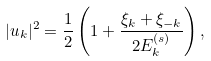<formula> <loc_0><loc_0><loc_500><loc_500>| u _ { k } | ^ { 2 } = \frac { 1 } { 2 } \left ( 1 + \frac { \xi _ { k } + \xi _ { - k } } { 2 E ^ { ( s ) } _ { k } } \right ) ,</formula> 